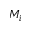<formula> <loc_0><loc_0><loc_500><loc_500>M _ { i }</formula> 